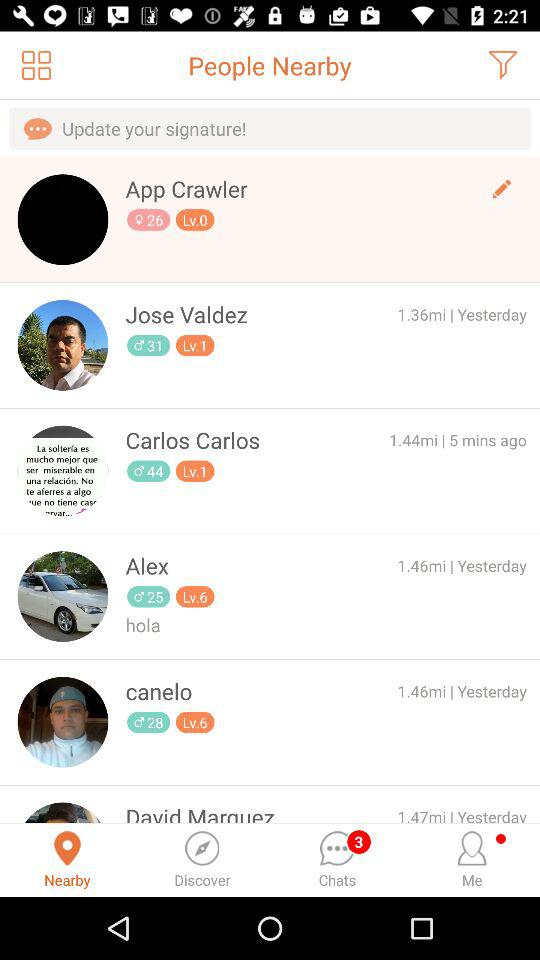What is the level of Canelo? The level of Canelo is 6. 